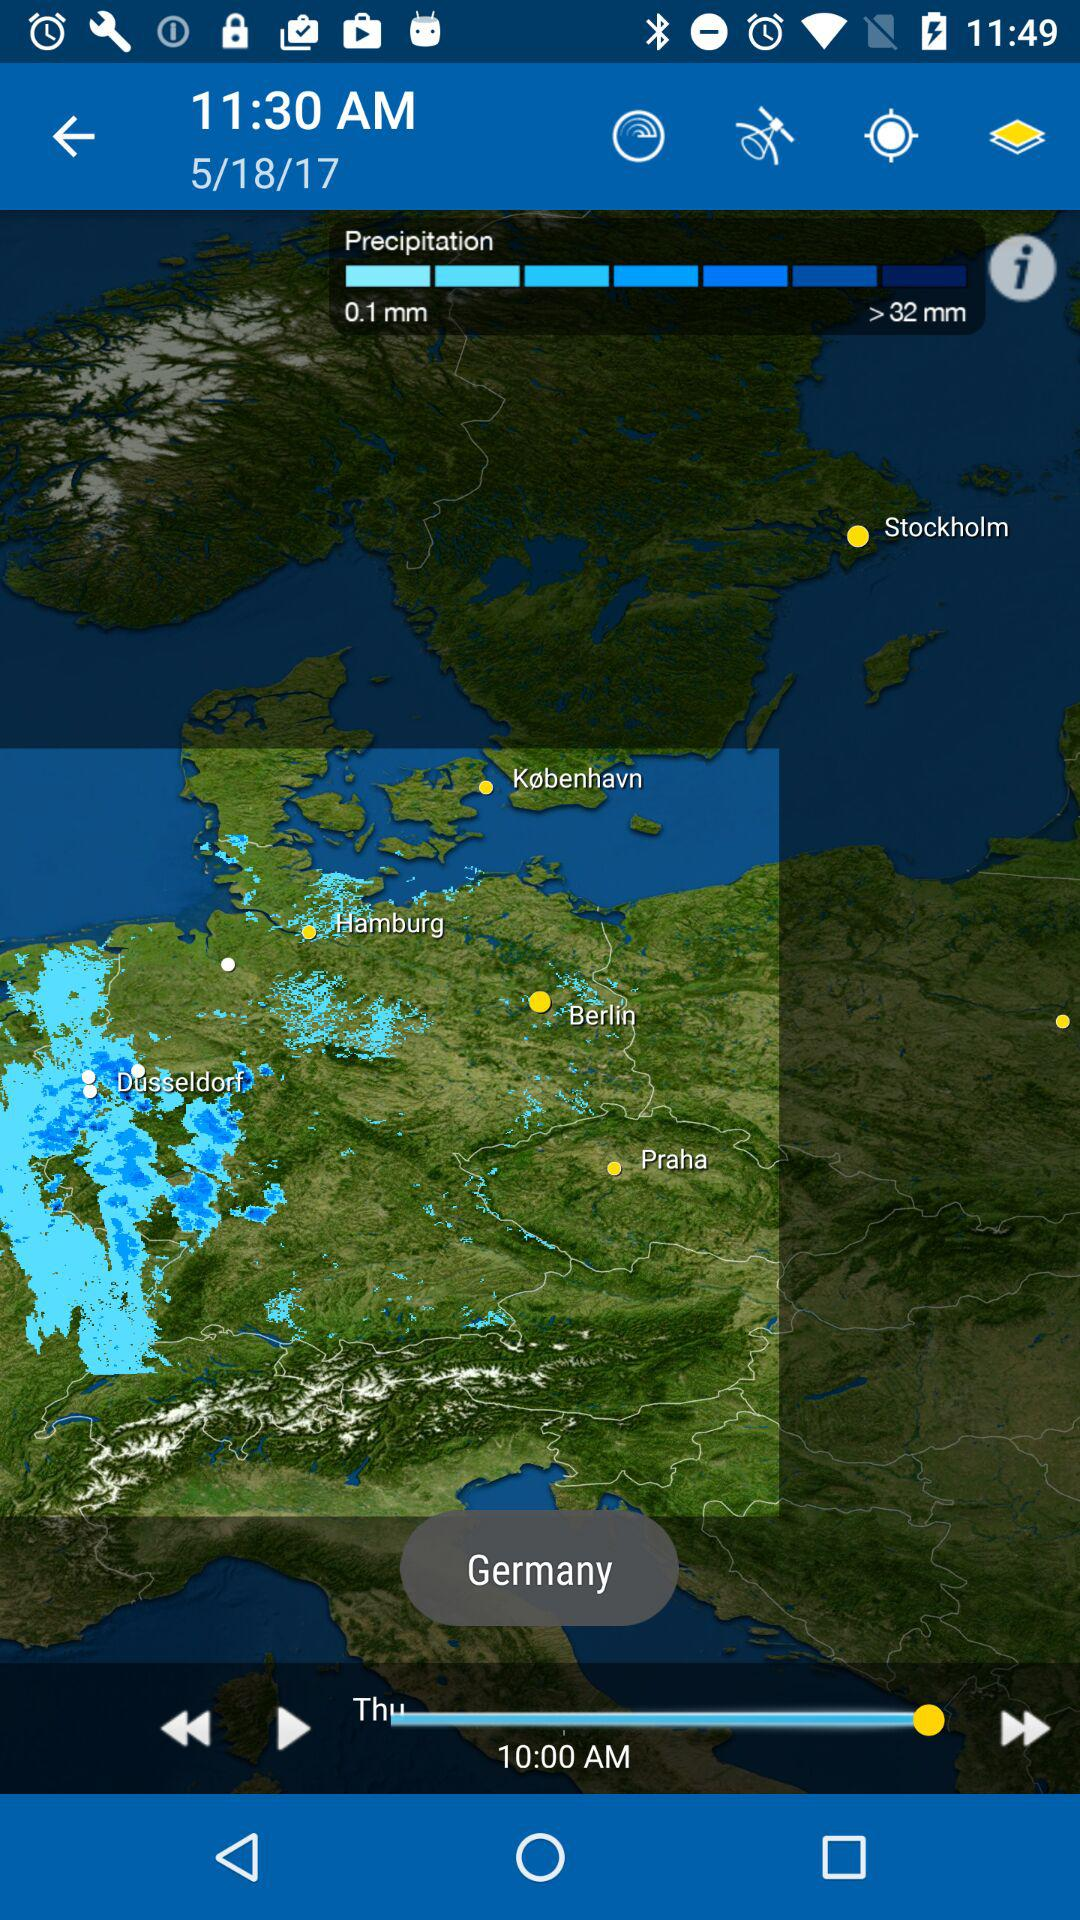What is the selected country? The selected country is Germany. 